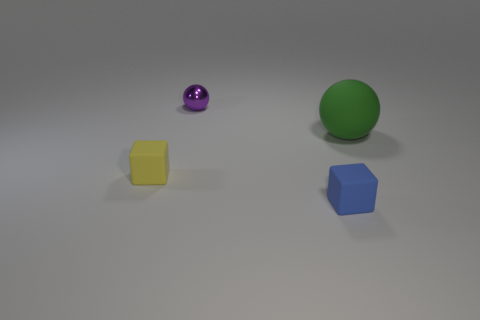Is there anything else that has the same size as the green matte object?
Make the answer very short. No. Do the blue cube and the green object have the same size?
Provide a short and direct response. No. What number of other objects are there of the same color as the large object?
Your answer should be compact. 0. Are there fewer tiny yellow objects in front of the tiny yellow rubber thing than purple things behind the big ball?
Give a very brief answer. Yes. What number of small metallic spheres are there?
Your answer should be very brief. 1. Is there any other thing that has the same material as the purple sphere?
Keep it short and to the point. No. What material is the large green object that is the same shape as the purple thing?
Give a very brief answer. Rubber. Are there fewer green matte balls that are behind the shiny sphere than small yellow matte objects?
Your response must be concise. Yes. Is the shape of the rubber object in front of the yellow matte object the same as  the green thing?
Make the answer very short. No. The yellow cube that is the same material as the green sphere is what size?
Provide a short and direct response. Small. 